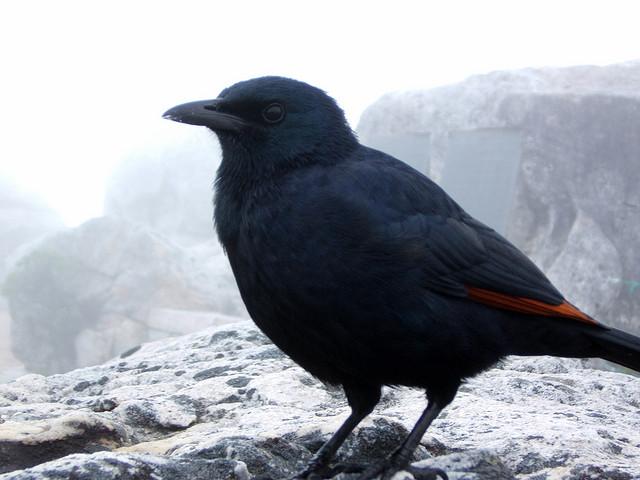What on the bird is red?
Keep it brief. Wing. Which way is the bird looking?
Be succinct. Left. What is the color of the bird?
Short answer required. Black. Is this a zoo?
Write a very short answer. No. Where's the birds unshown foot?
Answer briefly. On rock. 